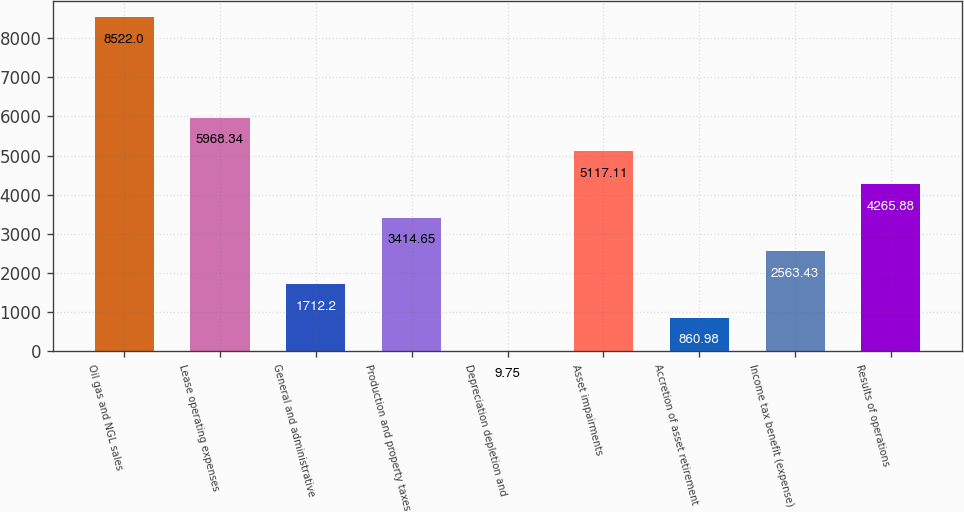<chart> <loc_0><loc_0><loc_500><loc_500><bar_chart><fcel>Oil gas and NGL sales<fcel>Lease operating expenses<fcel>General and administrative<fcel>Production and property taxes<fcel>Depreciation depletion and<fcel>Asset impairments<fcel>Accretion of asset retirement<fcel>Income tax benefit (expense)<fcel>Results of operations<nl><fcel>8522<fcel>5968.34<fcel>1712.2<fcel>3414.65<fcel>9.75<fcel>5117.11<fcel>860.98<fcel>2563.43<fcel>4265.88<nl></chart> 